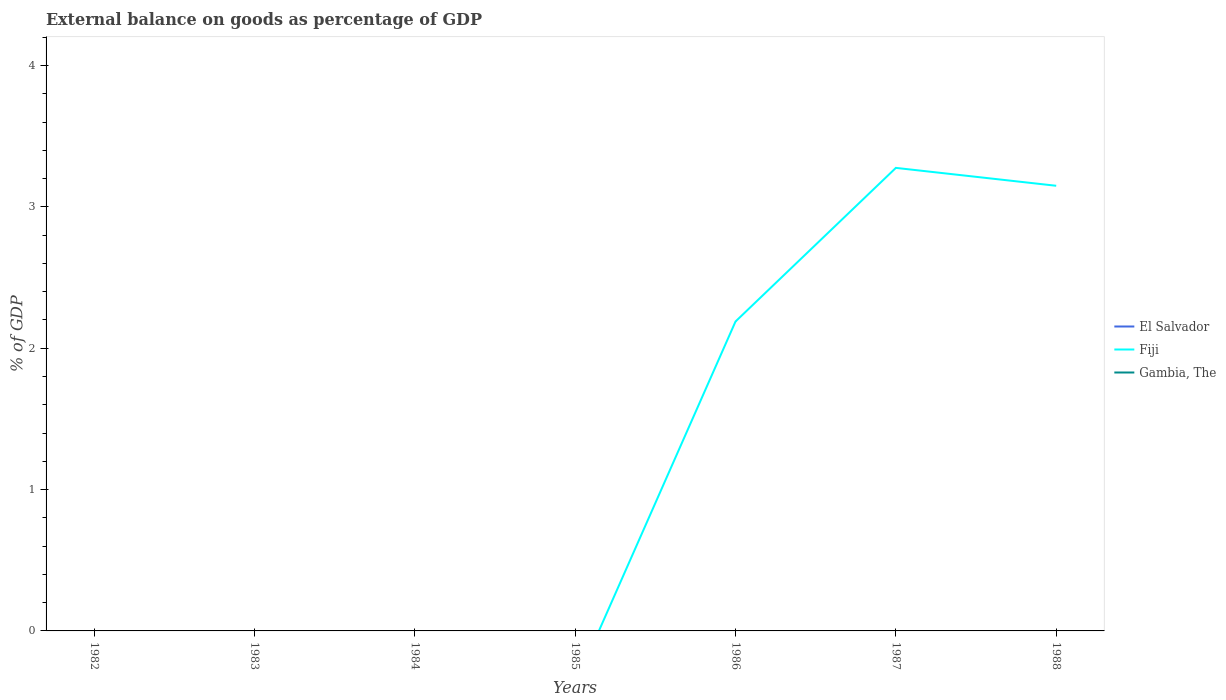Across all years, what is the maximum external balance on goods as percentage of GDP in Fiji?
Give a very brief answer. 0. What is the total external balance on goods as percentage of GDP in Fiji in the graph?
Keep it short and to the point. 0.13. What is the difference between the highest and the second highest external balance on goods as percentage of GDP in Fiji?
Ensure brevity in your answer.  3.28. What is the difference between the highest and the lowest external balance on goods as percentage of GDP in El Salvador?
Ensure brevity in your answer.  0. How many lines are there?
Ensure brevity in your answer.  1. How many years are there in the graph?
Offer a terse response. 7. Are the values on the major ticks of Y-axis written in scientific E-notation?
Provide a succinct answer. No. Does the graph contain grids?
Your response must be concise. No. How many legend labels are there?
Your response must be concise. 3. What is the title of the graph?
Provide a succinct answer. External balance on goods as percentage of GDP. Does "Mexico" appear as one of the legend labels in the graph?
Provide a succinct answer. No. What is the label or title of the Y-axis?
Provide a succinct answer. % of GDP. What is the % of GDP of Gambia, The in 1982?
Your answer should be very brief. 0. What is the % of GDP of El Salvador in 1983?
Your response must be concise. 0. What is the % of GDP in Fiji in 1983?
Ensure brevity in your answer.  0. What is the % of GDP in Fiji in 1984?
Ensure brevity in your answer.  0. What is the % of GDP of El Salvador in 1985?
Offer a terse response. 0. What is the % of GDP in Fiji in 1985?
Give a very brief answer. 0. What is the % of GDP of Fiji in 1986?
Provide a short and direct response. 2.19. What is the % of GDP in Gambia, The in 1986?
Ensure brevity in your answer.  0. What is the % of GDP of Fiji in 1987?
Provide a short and direct response. 3.28. What is the % of GDP in Fiji in 1988?
Keep it short and to the point. 3.15. What is the % of GDP in Gambia, The in 1988?
Offer a terse response. 0. Across all years, what is the maximum % of GDP in Fiji?
Your answer should be compact. 3.28. What is the total % of GDP in El Salvador in the graph?
Provide a succinct answer. 0. What is the total % of GDP in Fiji in the graph?
Your answer should be compact. 8.61. What is the difference between the % of GDP in Fiji in 1986 and that in 1987?
Provide a short and direct response. -1.09. What is the difference between the % of GDP of Fiji in 1986 and that in 1988?
Your answer should be very brief. -0.96. What is the difference between the % of GDP in Fiji in 1987 and that in 1988?
Give a very brief answer. 0.13. What is the average % of GDP of Fiji per year?
Ensure brevity in your answer.  1.23. What is the average % of GDP in Gambia, The per year?
Make the answer very short. 0. What is the ratio of the % of GDP of Fiji in 1986 to that in 1987?
Your answer should be compact. 0.67. What is the ratio of the % of GDP in Fiji in 1986 to that in 1988?
Keep it short and to the point. 0.7. What is the ratio of the % of GDP of Fiji in 1987 to that in 1988?
Your answer should be very brief. 1.04. What is the difference between the highest and the second highest % of GDP of Fiji?
Provide a succinct answer. 0.13. What is the difference between the highest and the lowest % of GDP of Fiji?
Offer a terse response. 3.28. 